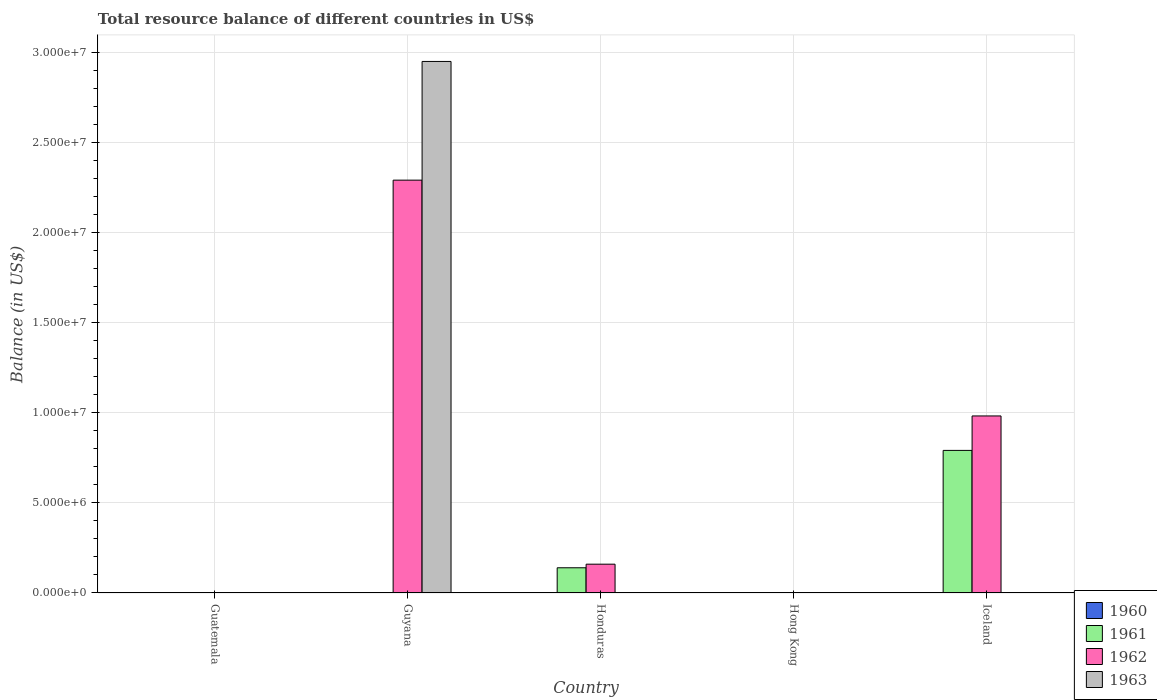How many different coloured bars are there?
Keep it short and to the point. 3. Are the number of bars per tick equal to the number of legend labels?
Keep it short and to the point. No. Are the number of bars on each tick of the X-axis equal?
Your answer should be compact. No. How many bars are there on the 5th tick from the right?
Keep it short and to the point. 0. Across all countries, what is the maximum total resource balance in 1963?
Ensure brevity in your answer.  2.95e+07. In which country was the total resource balance in 1961 maximum?
Make the answer very short. Iceland. What is the total total resource balance in 1962 in the graph?
Your answer should be very brief. 3.44e+07. What is the difference between the total resource balance in 1962 in Honduras and that in Iceland?
Ensure brevity in your answer.  -8.23e+06. What is the difference between the total resource balance in 1961 in Honduras and the total resource balance in 1963 in Iceland?
Offer a very short reply. 1.40e+06. What is the average total resource balance in 1961 per country?
Your answer should be very brief. 1.86e+06. What is the difference between the total resource balance of/in 1961 and total resource balance of/in 1962 in Honduras?
Give a very brief answer. -2.00e+05. In how many countries, is the total resource balance in 1963 greater than 18000000 US$?
Your response must be concise. 1. What is the ratio of the total resource balance in 1962 in Guyana to that in Iceland?
Your answer should be compact. 2.33. Is the total resource balance in 1962 in Honduras less than that in Iceland?
Give a very brief answer. Yes. What is the difference between the highest and the second highest total resource balance in 1962?
Ensure brevity in your answer.  -8.23e+06. What is the difference between the highest and the lowest total resource balance in 1961?
Keep it short and to the point. 7.92e+06. Is it the case that in every country, the sum of the total resource balance in 1960 and total resource balance in 1961 is greater than the total resource balance in 1963?
Your answer should be compact. No. Are all the bars in the graph horizontal?
Give a very brief answer. No. How many countries are there in the graph?
Offer a terse response. 5. What is the difference between two consecutive major ticks on the Y-axis?
Keep it short and to the point. 5.00e+06. What is the title of the graph?
Give a very brief answer. Total resource balance of different countries in US$. Does "1965" appear as one of the legend labels in the graph?
Offer a terse response. No. What is the label or title of the Y-axis?
Your answer should be very brief. Balance (in US$). What is the Balance (in US$) of 1961 in Guatemala?
Offer a very short reply. 0. What is the Balance (in US$) of 1963 in Guatemala?
Keep it short and to the point. 0. What is the Balance (in US$) in 1962 in Guyana?
Provide a succinct answer. 2.29e+07. What is the Balance (in US$) in 1963 in Guyana?
Provide a short and direct response. 2.95e+07. What is the Balance (in US$) in 1960 in Honduras?
Your answer should be compact. 0. What is the Balance (in US$) in 1961 in Honduras?
Provide a succinct answer. 1.40e+06. What is the Balance (in US$) in 1962 in Honduras?
Make the answer very short. 1.60e+06. What is the Balance (in US$) of 1963 in Honduras?
Keep it short and to the point. 0. What is the Balance (in US$) in 1960 in Hong Kong?
Your response must be concise. 0. What is the Balance (in US$) of 1961 in Hong Kong?
Your response must be concise. 0. What is the Balance (in US$) of 1961 in Iceland?
Your answer should be very brief. 7.92e+06. What is the Balance (in US$) of 1962 in Iceland?
Make the answer very short. 9.83e+06. Across all countries, what is the maximum Balance (in US$) in 1961?
Make the answer very short. 7.92e+06. Across all countries, what is the maximum Balance (in US$) in 1962?
Give a very brief answer. 2.29e+07. Across all countries, what is the maximum Balance (in US$) of 1963?
Give a very brief answer. 2.95e+07. Across all countries, what is the minimum Balance (in US$) in 1961?
Keep it short and to the point. 0. Across all countries, what is the minimum Balance (in US$) of 1962?
Your answer should be compact. 0. What is the total Balance (in US$) of 1960 in the graph?
Offer a terse response. 0. What is the total Balance (in US$) of 1961 in the graph?
Make the answer very short. 9.32e+06. What is the total Balance (in US$) in 1962 in the graph?
Your answer should be very brief. 3.44e+07. What is the total Balance (in US$) in 1963 in the graph?
Keep it short and to the point. 2.95e+07. What is the difference between the Balance (in US$) in 1962 in Guyana and that in Honduras?
Offer a very short reply. 2.13e+07. What is the difference between the Balance (in US$) of 1962 in Guyana and that in Iceland?
Offer a very short reply. 1.31e+07. What is the difference between the Balance (in US$) in 1961 in Honduras and that in Iceland?
Your answer should be very brief. -6.52e+06. What is the difference between the Balance (in US$) of 1962 in Honduras and that in Iceland?
Your answer should be very brief. -8.23e+06. What is the difference between the Balance (in US$) of 1961 in Honduras and the Balance (in US$) of 1962 in Iceland?
Your response must be concise. -8.43e+06. What is the average Balance (in US$) in 1960 per country?
Offer a terse response. 0. What is the average Balance (in US$) in 1961 per country?
Make the answer very short. 1.86e+06. What is the average Balance (in US$) of 1962 per country?
Offer a terse response. 6.87e+06. What is the average Balance (in US$) in 1963 per country?
Your response must be concise. 5.90e+06. What is the difference between the Balance (in US$) in 1962 and Balance (in US$) in 1963 in Guyana?
Ensure brevity in your answer.  -6.59e+06. What is the difference between the Balance (in US$) in 1961 and Balance (in US$) in 1962 in Honduras?
Your answer should be compact. -2.00e+05. What is the difference between the Balance (in US$) of 1961 and Balance (in US$) of 1962 in Iceland?
Offer a very short reply. -1.91e+06. What is the ratio of the Balance (in US$) of 1962 in Guyana to that in Honduras?
Keep it short and to the point. 14.33. What is the ratio of the Balance (in US$) of 1962 in Guyana to that in Iceland?
Offer a terse response. 2.33. What is the ratio of the Balance (in US$) in 1961 in Honduras to that in Iceland?
Give a very brief answer. 0.18. What is the ratio of the Balance (in US$) of 1962 in Honduras to that in Iceland?
Make the answer very short. 0.16. What is the difference between the highest and the second highest Balance (in US$) in 1962?
Your answer should be very brief. 1.31e+07. What is the difference between the highest and the lowest Balance (in US$) of 1961?
Offer a terse response. 7.92e+06. What is the difference between the highest and the lowest Balance (in US$) in 1962?
Provide a succinct answer. 2.29e+07. What is the difference between the highest and the lowest Balance (in US$) in 1963?
Your response must be concise. 2.95e+07. 